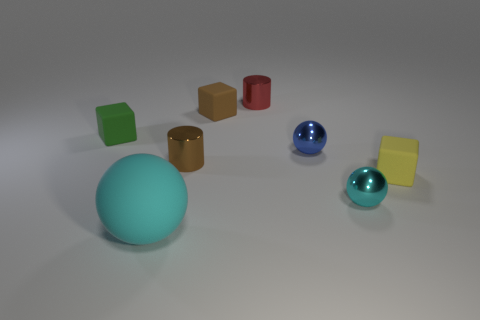The other thing that is the same color as the large matte object is what shape?
Ensure brevity in your answer.  Sphere. What number of things are either rubber blocks or small blocks on the left side of the blue metallic thing?
Provide a short and direct response. 3. What shape is the object that is in front of the yellow block and right of the big thing?
Provide a succinct answer. Sphere. What material is the tiny cube in front of the tiny rubber block that is left of the cyan matte sphere made of?
Give a very brief answer. Rubber. Is the material of the cylinder that is right of the brown metallic thing the same as the green cube?
Provide a succinct answer. No. There is a shiny cylinder left of the red metallic thing; what is its size?
Your answer should be very brief. Small. Is there a tiny cyan metal object behind the cyan thing that is to the left of the tiny red thing?
Make the answer very short. Yes. Is the color of the small matte cube that is to the left of the large rubber ball the same as the metallic sphere in front of the tiny brown shiny cylinder?
Your answer should be compact. No. What color is the large sphere?
Provide a succinct answer. Cyan. Is there anything else that has the same color as the large rubber sphere?
Provide a succinct answer. Yes. 